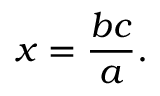Convert formula to latex. <formula><loc_0><loc_0><loc_500><loc_500>x = { \frac { b c } { a } } .</formula> 